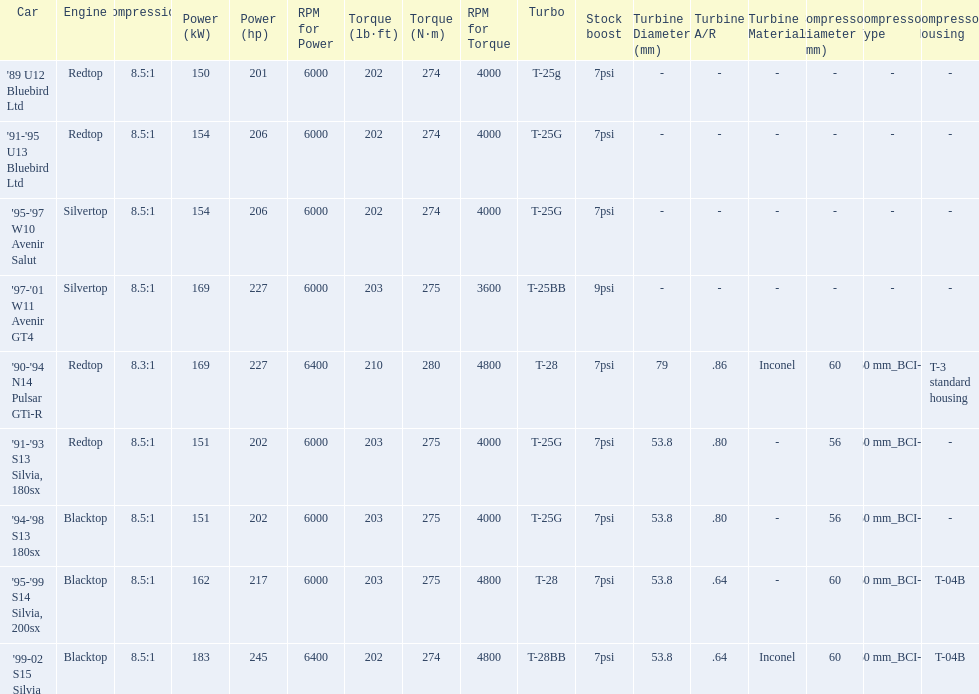Which of the cars uses the redtop engine? '89 U12 Bluebird Ltd, '91-'95 U13 Bluebird Ltd, '90-'94 N14 Pulsar GTi-R, '91-'93 S13 Silvia, 180sx. Of these, has more than 220 horsepower? '90-'94 N14 Pulsar GTi-R. What is the compression ratio of this car? 8.3:1. 